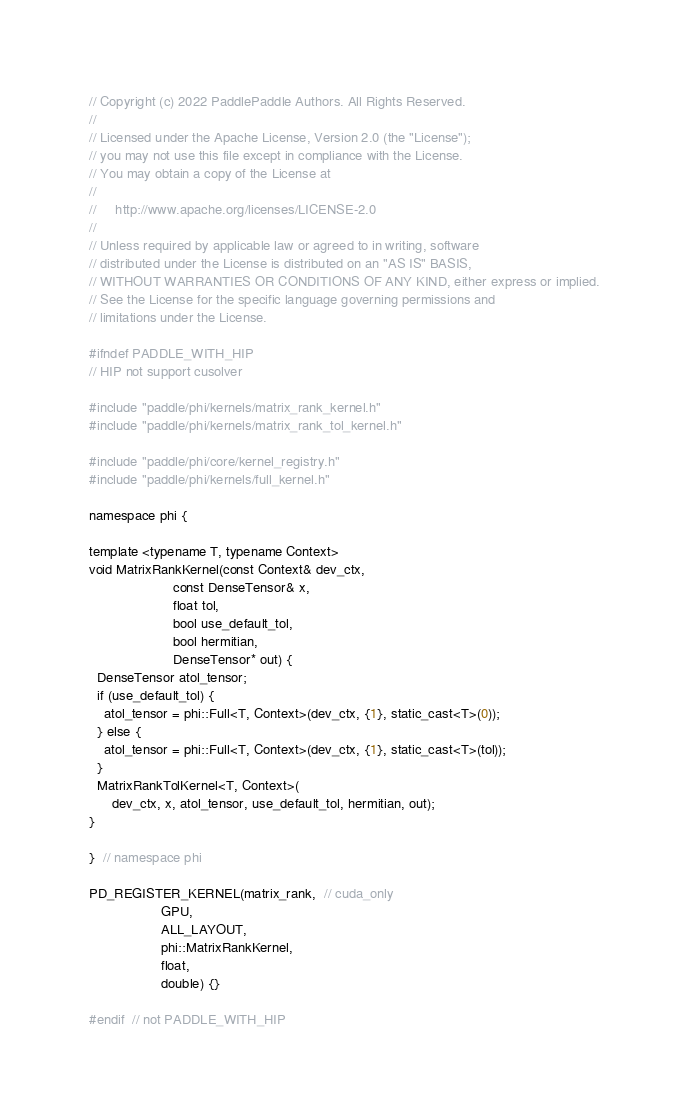<code> <loc_0><loc_0><loc_500><loc_500><_Cuda_>// Copyright (c) 2022 PaddlePaddle Authors. All Rights Reserved.
//
// Licensed under the Apache License, Version 2.0 (the "License");
// you may not use this file except in compliance with the License.
// You may obtain a copy of the License at
//
//     http://www.apache.org/licenses/LICENSE-2.0
//
// Unless required by applicable law or agreed to in writing, software
// distributed under the License is distributed on an "AS IS" BASIS,
// WITHOUT WARRANTIES OR CONDITIONS OF ANY KIND, either express or implied.
// See the License for the specific language governing permissions and
// limitations under the License.

#ifndef PADDLE_WITH_HIP
// HIP not support cusolver

#include "paddle/phi/kernels/matrix_rank_kernel.h"
#include "paddle/phi/kernels/matrix_rank_tol_kernel.h"

#include "paddle/phi/core/kernel_registry.h"
#include "paddle/phi/kernels/full_kernel.h"

namespace phi {

template <typename T, typename Context>
void MatrixRankKernel(const Context& dev_ctx,
                      const DenseTensor& x,
                      float tol,
                      bool use_default_tol,
                      bool hermitian,
                      DenseTensor* out) {
  DenseTensor atol_tensor;
  if (use_default_tol) {
    atol_tensor = phi::Full<T, Context>(dev_ctx, {1}, static_cast<T>(0));
  } else {
    atol_tensor = phi::Full<T, Context>(dev_ctx, {1}, static_cast<T>(tol));
  }
  MatrixRankTolKernel<T, Context>(
      dev_ctx, x, atol_tensor, use_default_tol, hermitian, out);
}

}  // namespace phi

PD_REGISTER_KERNEL(matrix_rank,  // cuda_only
                   GPU,
                   ALL_LAYOUT,
                   phi::MatrixRankKernel,
                   float,
                   double) {}

#endif  // not PADDLE_WITH_HIP
</code> 